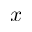Convert formula to latex. <formula><loc_0><loc_0><loc_500><loc_500>x</formula> 